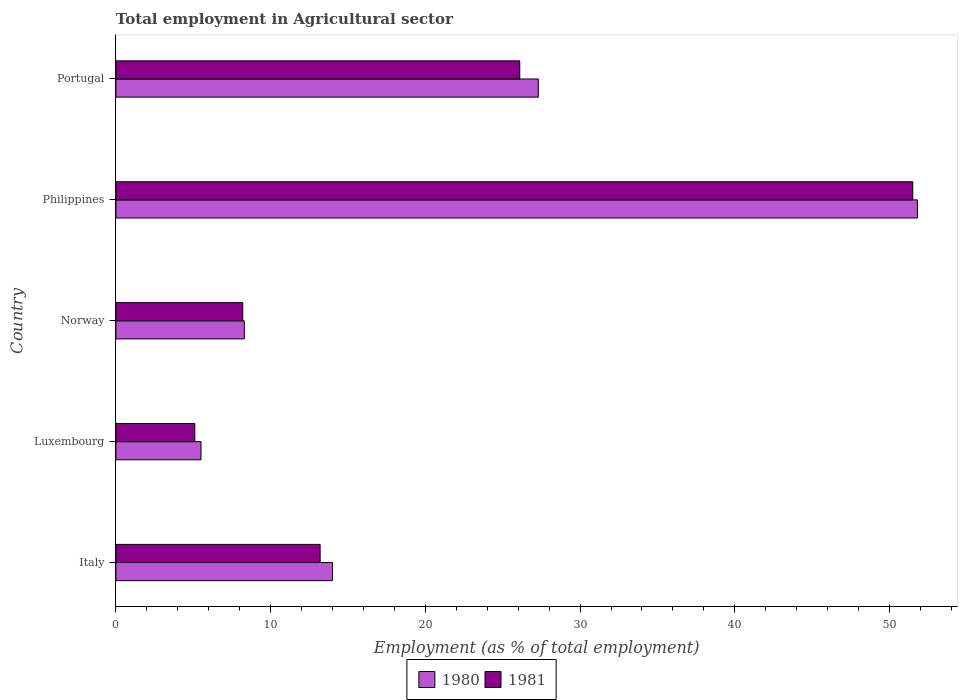In how many cases, is the number of bars for a given country not equal to the number of legend labels?
Offer a terse response. 0. What is the employment in agricultural sector in 1980 in Norway?
Your answer should be very brief. 8.3. Across all countries, what is the maximum employment in agricultural sector in 1980?
Your answer should be very brief. 51.8. Across all countries, what is the minimum employment in agricultural sector in 1981?
Offer a very short reply. 5.1. In which country was the employment in agricultural sector in 1980 minimum?
Offer a very short reply. Luxembourg. What is the total employment in agricultural sector in 1981 in the graph?
Make the answer very short. 104.1. What is the difference between the employment in agricultural sector in 1981 in Luxembourg and that in Philippines?
Ensure brevity in your answer.  -46.4. What is the difference between the employment in agricultural sector in 1980 in Luxembourg and the employment in agricultural sector in 1981 in Norway?
Your response must be concise. -2.7. What is the average employment in agricultural sector in 1980 per country?
Give a very brief answer. 21.38. What is the difference between the employment in agricultural sector in 1981 and employment in agricultural sector in 1980 in Norway?
Give a very brief answer. -0.1. In how many countries, is the employment in agricultural sector in 1981 greater than 38 %?
Your answer should be compact. 1. What is the ratio of the employment in agricultural sector in 1981 in Luxembourg to that in Norway?
Give a very brief answer. 0.62. Is the employment in agricultural sector in 1981 in Luxembourg less than that in Portugal?
Your answer should be very brief. Yes. Is the difference between the employment in agricultural sector in 1981 in Luxembourg and Portugal greater than the difference between the employment in agricultural sector in 1980 in Luxembourg and Portugal?
Your response must be concise. Yes. What is the difference between the highest and the second highest employment in agricultural sector in 1981?
Provide a succinct answer. 25.4. What is the difference between the highest and the lowest employment in agricultural sector in 1981?
Your answer should be very brief. 46.4. What does the 2nd bar from the top in Norway represents?
Offer a very short reply. 1980. How many countries are there in the graph?
Your response must be concise. 5. How many legend labels are there?
Provide a succinct answer. 2. What is the title of the graph?
Give a very brief answer. Total employment in Agricultural sector. Does "1986" appear as one of the legend labels in the graph?
Provide a short and direct response. No. What is the label or title of the X-axis?
Offer a very short reply. Employment (as % of total employment). What is the Employment (as % of total employment) in 1981 in Italy?
Provide a succinct answer. 13.2. What is the Employment (as % of total employment) in 1980 in Luxembourg?
Offer a terse response. 5.5. What is the Employment (as % of total employment) of 1981 in Luxembourg?
Provide a succinct answer. 5.1. What is the Employment (as % of total employment) in 1980 in Norway?
Make the answer very short. 8.3. What is the Employment (as % of total employment) in 1981 in Norway?
Your response must be concise. 8.2. What is the Employment (as % of total employment) in 1980 in Philippines?
Your response must be concise. 51.8. What is the Employment (as % of total employment) of 1981 in Philippines?
Make the answer very short. 51.5. What is the Employment (as % of total employment) in 1980 in Portugal?
Your answer should be compact. 27.3. What is the Employment (as % of total employment) of 1981 in Portugal?
Your answer should be very brief. 26.1. Across all countries, what is the maximum Employment (as % of total employment) in 1980?
Provide a succinct answer. 51.8. Across all countries, what is the maximum Employment (as % of total employment) of 1981?
Provide a short and direct response. 51.5. Across all countries, what is the minimum Employment (as % of total employment) in 1980?
Your answer should be very brief. 5.5. Across all countries, what is the minimum Employment (as % of total employment) in 1981?
Your response must be concise. 5.1. What is the total Employment (as % of total employment) of 1980 in the graph?
Your response must be concise. 106.9. What is the total Employment (as % of total employment) of 1981 in the graph?
Your response must be concise. 104.1. What is the difference between the Employment (as % of total employment) in 1980 in Italy and that in Luxembourg?
Your response must be concise. 8.5. What is the difference between the Employment (as % of total employment) of 1980 in Italy and that in Norway?
Offer a very short reply. 5.7. What is the difference between the Employment (as % of total employment) of 1980 in Italy and that in Philippines?
Give a very brief answer. -37.8. What is the difference between the Employment (as % of total employment) of 1981 in Italy and that in Philippines?
Provide a short and direct response. -38.3. What is the difference between the Employment (as % of total employment) of 1981 in Italy and that in Portugal?
Give a very brief answer. -12.9. What is the difference between the Employment (as % of total employment) of 1980 in Luxembourg and that in Philippines?
Ensure brevity in your answer.  -46.3. What is the difference between the Employment (as % of total employment) of 1981 in Luxembourg and that in Philippines?
Ensure brevity in your answer.  -46.4. What is the difference between the Employment (as % of total employment) in 1980 in Luxembourg and that in Portugal?
Make the answer very short. -21.8. What is the difference between the Employment (as % of total employment) in 1981 in Luxembourg and that in Portugal?
Offer a very short reply. -21. What is the difference between the Employment (as % of total employment) in 1980 in Norway and that in Philippines?
Your response must be concise. -43.5. What is the difference between the Employment (as % of total employment) in 1981 in Norway and that in Philippines?
Offer a terse response. -43.3. What is the difference between the Employment (as % of total employment) in 1980 in Norway and that in Portugal?
Keep it short and to the point. -19. What is the difference between the Employment (as % of total employment) in 1981 in Norway and that in Portugal?
Your answer should be very brief. -17.9. What is the difference between the Employment (as % of total employment) of 1981 in Philippines and that in Portugal?
Make the answer very short. 25.4. What is the difference between the Employment (as % of total employment) in 1980 in Italy and the Employment (as % of total employment) in 1981 in Luxembourg?
Offer a terse response. 8.9. What is the difference between the Employment (as % of total employment) of 1980 in Italy and the Employment (as % of total employment) of 1981 in Philippines?
Give a very brief answer. -37.5. What is the difference between the Employment (as % of total employment) in 1980 in Luxembourg and the Employment (as % of total employment) in 1981 in Philippines?
Give a very brief answer. -46. What is the difference between the Employment (as % of total employment) in 1980 in Luxembourg and the Employment (as % of total employment) in 1981 in Portugal?
Provide a succinct answer. -20.6. What is the difference between the Employment (as % of total employment) of 1980 in Norway and the Employment (as % of total employment) of 1981 in Philippines?
Offer a very short reply. -43.2. What is the difference between the Employment (as % of total employment) in 1980 in Norway and the Employment (as % of total employment) in 1981 in Portugal?
Offer a terse response. -17.8. What is the difference between the Employment (as % of total employment) in 1980 in Philippines and the Employment (as % of total employment) in 1981 in Portugal?
Give a very brief answer. 25.7. What is the average Employment (as % of total employment) of 1980 per country?
Give a very brief answer. 21.38. What is the average Employment (as % of total employment) of 1981 per country?
Offer a terse response. 20.82. What is the difference between the Employment (as % of total employment) of 1980 and Employment (as % of total employment) of 1981 in Portugal?
Your response must be concise. 1.2. What is the ratio of the Employment (as % of total employment) in 1980 in Italy to that in Luxembourg?
Offer a very short reply. 2.55. What is the ratio of the Employment (as % of total employment) in 1981 in Italy to that in Luxembourg?
Provide a succinct answer. 2.59. What is the ratio of the Employment (as % of total employment) of 1980 in Italy to that in Norway?
Offer a very short reply. 1.69. What is the ratio of the Employment (as % of total employment) of 1981 in Italy to that in Norway?
Your answer should be very brief. 1.61. What is the ratio of the Employment (as % of total employment) in 1980 in Italy to that in Philippines?
Offer a terse response. 0.27. What is the ratio of the Employment (as % of total employment) in 1981 in Italy to that in Philippines?
Give a very brief answer. 0.26. What is the ratio of the Employment (as % of total employment) in 1980 in Italy to that in Portugal?
Make the answer very short. 0.51. What is the ratio of the Employment (as % of total employment) in 1981 in Italy to that in Portugal?
Your response must be concise. 0.51. What is the ratio of the Employment (as % of total employment) of 1980 in Luxembourg to that in Norway?
Offer a very short reply. 0.66. What is the ratio of the Employment (as % of total employment) in 1981 in Luxembourg to that in Norway?
Give a very brief answer. 0.62. What is the ratio of the Employment (as % of total employment) in 1980 in Luxembourg to that in Philippines?
Keep it short and to the point. 0.11. What is the ratio of the Employment (as % of total employment) of 1981 in Luxembourg to that in Philippines?
Offer a very short reply. 0.1. What is the ratio of the Employment (as % of total employment) in 1980 in Luxembourg to that in Portugal?
Your answer should be compact. 0.2. What is the ratio of the Employment (as % of total employment) of 1981 in Luxembourg to that in Portugal?
Your answer should be very brief. 0.2. What is the ratio of the Employment (as % of total employment) of 1980 in Norway to that in Philippines?
Offer a terse response. 0.16. What is the ratio of the Employment (as % of total employment) in 1981 in Norway to that in Philippines?
Give a very brief answer. 0.16. What is the ratio of the Employment (as % of total employment) in 1980 in Norway to that in Portugal?
Make the answer very short. 0.3. What is the ratio of the Employment (as % of total employment) of 1981 in Norway to that in Portugal?
Ensure brevity in your answer.  0.31. What is the ratio of the Employment (as % of total employment) of 1980 in Philippines to that in Portugal?
Your answer should be very brief. 1.9. What is the ratio of the Employment (as % of total employment) of 1981 in Philippines to that in Portugal?
Offer a terse response. 1.97. What is the difference between the highest and the second highest Employment (as % of total employment) in 1981?
Provide a short and direct response. 25.4. What is the difference between the highest and the lowest Employment (as % of total employment) of 1980?
Provide a short and direct response. 46.3. What is the difference between the highest and the lowest Employment (as % of total employment) of 1981?
Provide a short and direct response. 46.4. 